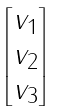<formula> <loc_0><loc_0><loc_500><loc_500>\begin{bmatrix} v _ { 1 } \\ v _ { 2 } \\ v _ { 3 } \end{bmatrix}</formula> 